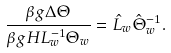<formula> <loc_0><loc_0><loc_500><loc_500>\frac { \beta g \Delta \Theta } { \beta g H L _ { w } ^ { - 1 } \Theta _ { w } } = \hat { L } _ { w } \hat { \Theta } _ { w } ^ { - 1 } .</formula> 